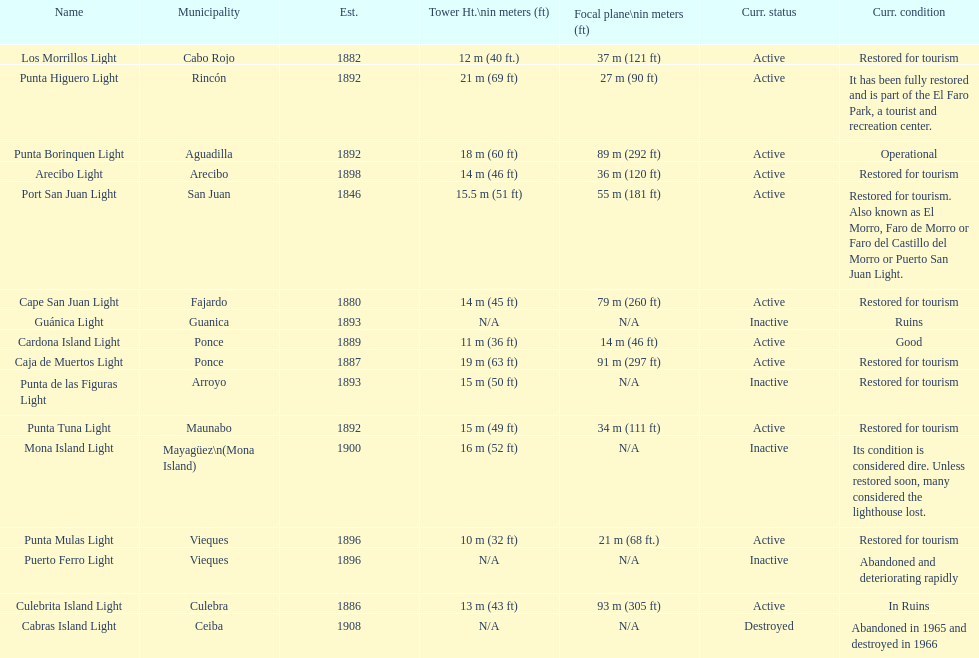The range in years between 1882 and 1889 7. 